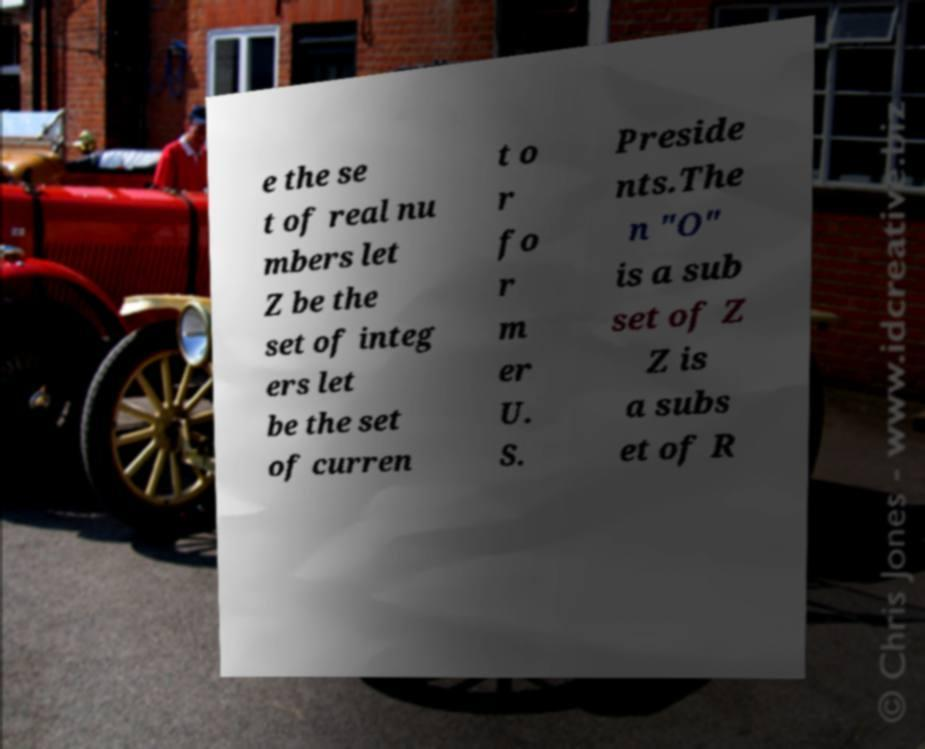What messages or text are displayed in this image? I need them in a readable, typed format. e the se t of real nu mbers let Z be the set of integ ers let be the set of curren t o r fo r m er U. S. Preside nts.The n "O" is a sub set of Z Z is a subs et of R 